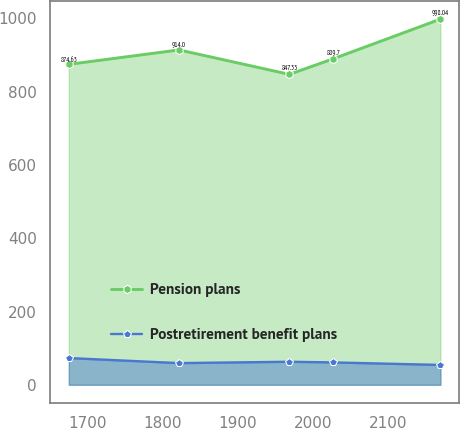<chart> <loc_0><loc_0><loc_500><loc_500><line_chart><ecel><fcel>Pension plans<fcel>Postretirement benefit plans<nl><fcel>1675.58<fcel>874.63<fcel>72.95<nl><fcel>1821.98<fcel>914<fcel>59.16<nl><fcel>1968.52<fcel>847.33<fcel>62.91<nl><fcel>2026.75<fcel>889.7<fcel>61.03<nl><fcel>2169.23<fcel>998.04<fcel>54.2<nl></chart> 